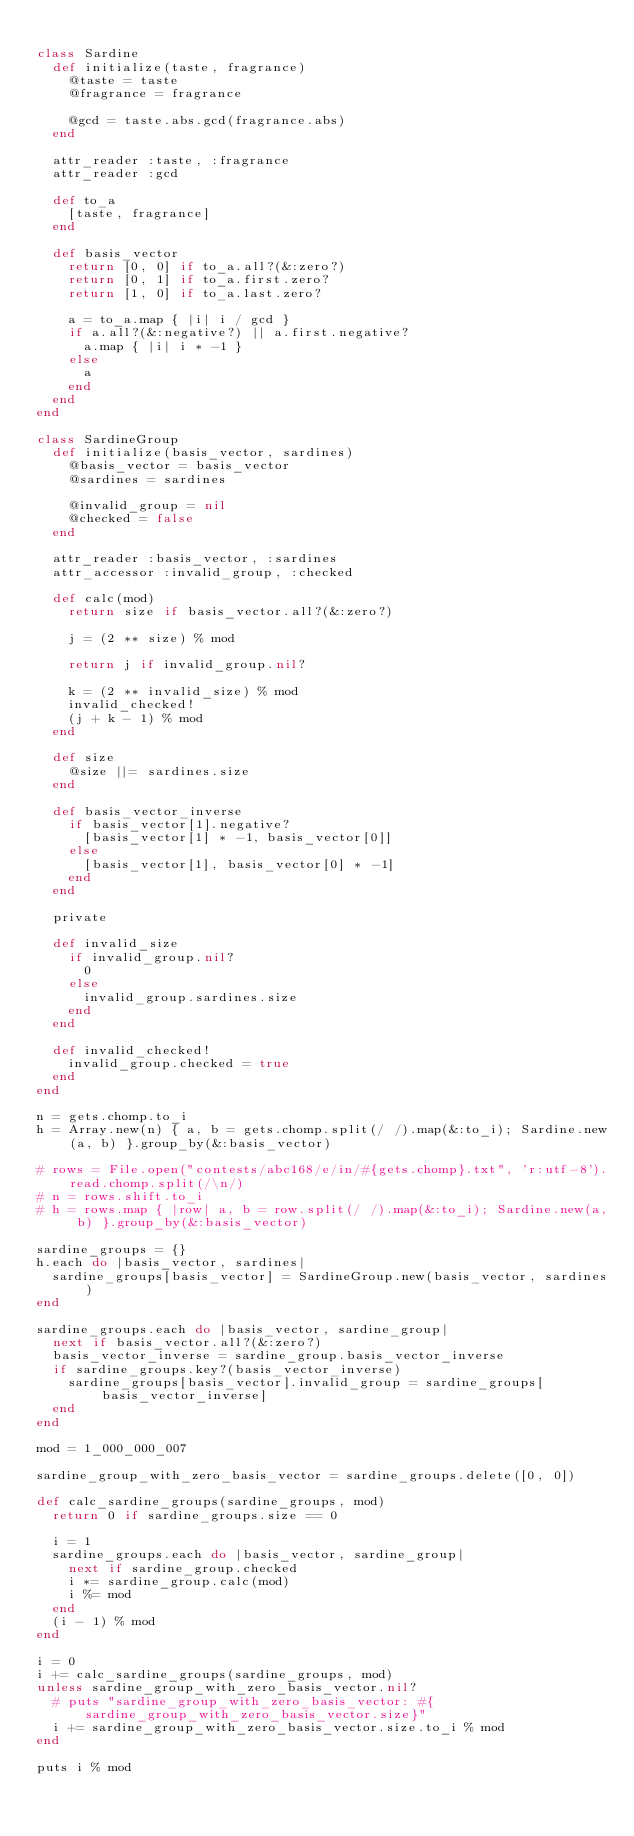<code> <loc_0><loc_0><loc_500><loc_500><_Ruby_>
class Sardine
  def initialize(taste, fragrance)
    @taste = taste
    @fragrance = fragrance

    @gcd = taste.abs.gcd(fragrance.abs)
  end

  attr_reader :taste, :fragrance
  attr_reader :gcd

  def to_a
    [taste, fragrance]
  end

  def basis_vector
    return [0, 0] if to_a.all?(&:zero?)
    return [0, 1] if to_a.first.zero?
    return [1, 0] if to_a.last.zero?

    a = to_a.map { |i| i / gcd }
    if a.all?(&:negative?) || a.first.negative?
      a.map { |i| i * -1 }
    else
      a
    end
  end
end

class SardineGroup
  def initialize(basis_vector, sardines)
    @basis_vector = basis_vector
    @sardines = sardines

    @invalid_group = nil
    @checked = false
  end

  attr_reader :basis_vector, :sardines
  attr_accessor :invalid_group, :checked

  def calc(mod)
    return size if basis_vector.all?(&:zero?)

    j = (2 ** size) % mod

    return j if invalid_group.nil?

    k = (2 ** invalid_size) % mod
    invalid_checked!
    (j + k - 1) % mod
  end

  def size
    @size ||= sardines.size
  end

  def basis_vector_inverse
    if basis_vector[1].negative?
      [basis_vector[1] * -1, basis_vector[0]]
    else
      [basis_vector[1], basis_vector[0] * -1]
    end
  end

  private

  def invalid_size
    if invalid_group.nil?
      0
    else
      invalid_group.sardines.size
    end
  end

  def invalid_checked!
    invalid_group.checked = true
  end
end

n = gets.chomp.to_i
h = Array.new(n) { a, b = gets.chomp.split(/ /).map(&:to_i); Sardine.new(a, b) }.group_by(&:basis_vector)

# rows = File.open("contests/abc168/e/in/#{gets.chomp}.txt", 'r:utf-8').read.chomp.split(/\n/)
# n = rows.shift.to_i
# h = rows.map { |row| a, b = row.split(/ /).map(&:to_i); Sardine.new(a, b) }.group_by(&:basis_vector)

sardine_groups = {}
h.each do |basis_vector, sardines|
  sardine_groups[basis_vector] = SardineGroup.new(basis_vector, sardines)
end

sardine_groups.each do |basis_vector, sardine_group|
  next if basis_vector.all?(&:zero?)
  basis_vector_inverse = sardine_group.basis_vector_inverse
  if sardine_groups.key?(basis_vector_inverse)
    sardine_groups[basis_vector].invalid_group = sardine_groups[basis_vector_inverse]
  end
end

mod = 1_000_000_007

sardine_group_with_zero_basis_vector = sardine_groups.delete([0, 0])

def calc_sardine_groups(sardine_groups, mod)
  return 0 if sardine_groups.size == 0

  i = 1
  sardine_groups.each do |basis_vector, sardine_group|
    next if sardine_group.checked
    i *= sardine_group.calc(mod)
    i %= mod
  end
  (i - 1) % mod
end

i = 0
i += calc_sardine_groups(sardine_groups, mod)
unless sardine_group_with_zero_basis_vector.nil?
  # puts "sardine_group_with_zero_basis_vector: #{sardine_group_with_zero_basis_vector.size}"
  i += sardine_group_with_zero_basis_vector.size.to_i % mod
end

puts i % mod
</code> 